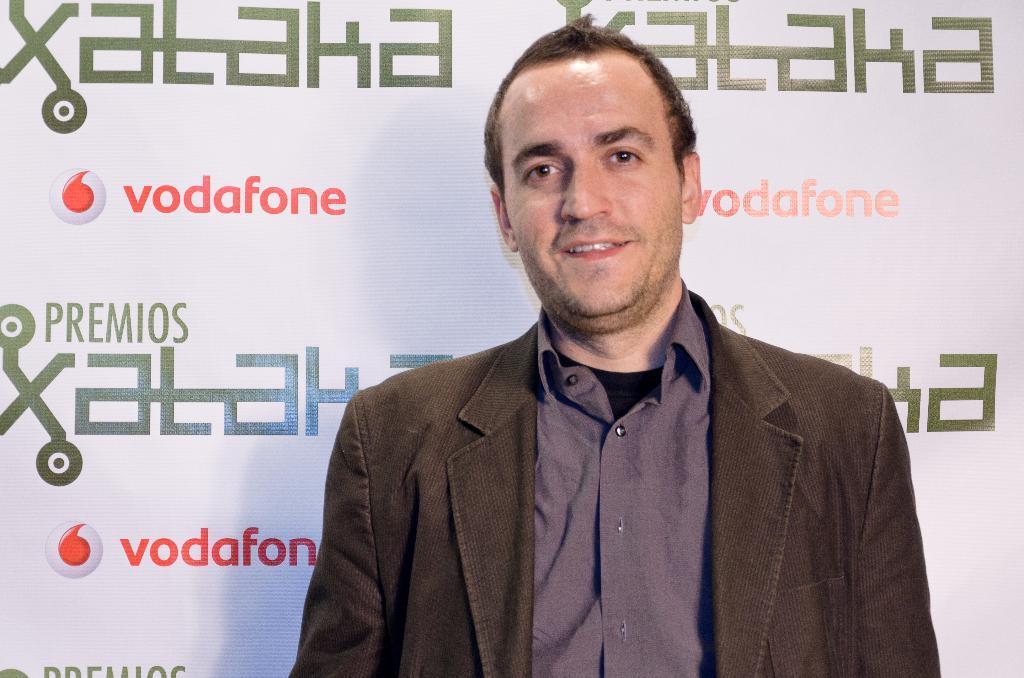Could you give a brief overview of what you see in this image? In this image I can see the person with dark brown and the purple color dress and the person is smiling. In the back I can see the banner and there is a name Vodafone is written on it. 